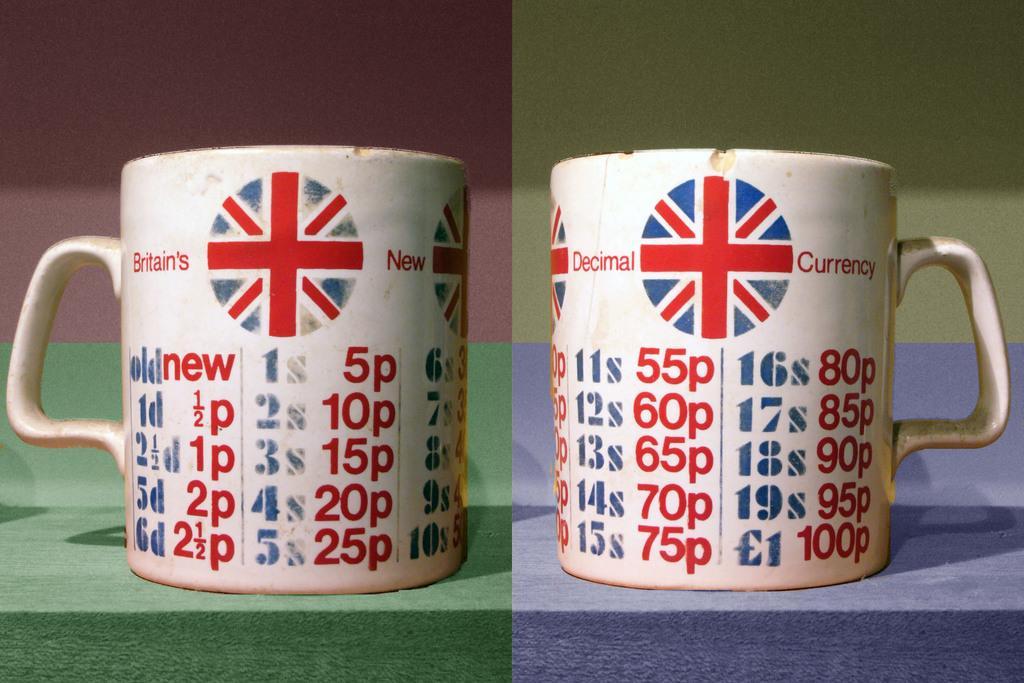Describe this image in one or two sentences. In this image we can see there is a collage picture of cups with logo and text written on it. 